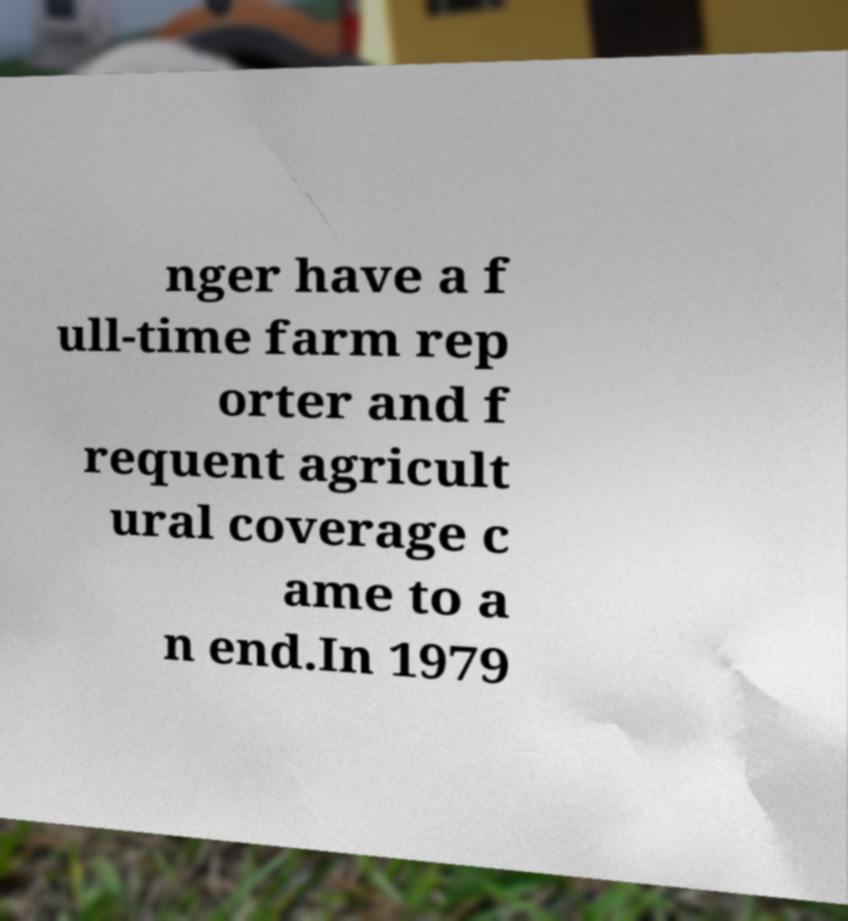For documentation purposes, I need the text within this image transcribed. Could you provide that? nger have a f ull-time farm rep orter and f requent agricult ural coverage c ame to a n end.In 1979 